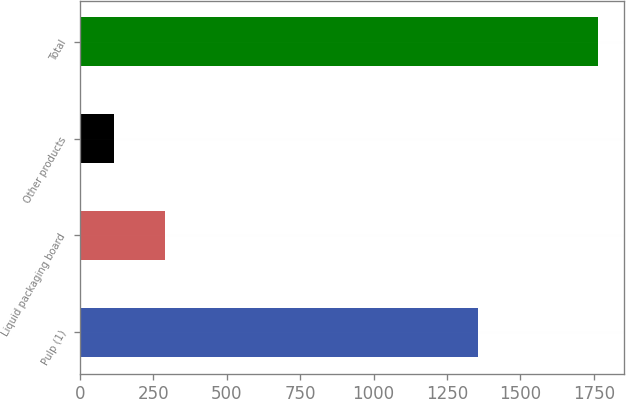Convert chart to OTSL. <chart><loc_0><loc_0><loc_500><loc_500><bar_chart><fcel>Pulp (1)<fcel>Liquid packaging board<fcel>Other products<fcel>Total<nl><fcel>1357<fcel>290<fcel>118<fcel>1765<nl></chart> 